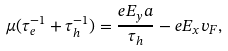Convert formula to latex. <formula><loc_0><loc_0><loc_500><loc_500>\mu ( \tau _ { e } ^ { - 1 } + \tau _ { h } ^ { - 1 } ) = \frac { e E _ { y } a } { \tau _ { h } } - e E _ { x } v _ { F } ,</formula> 